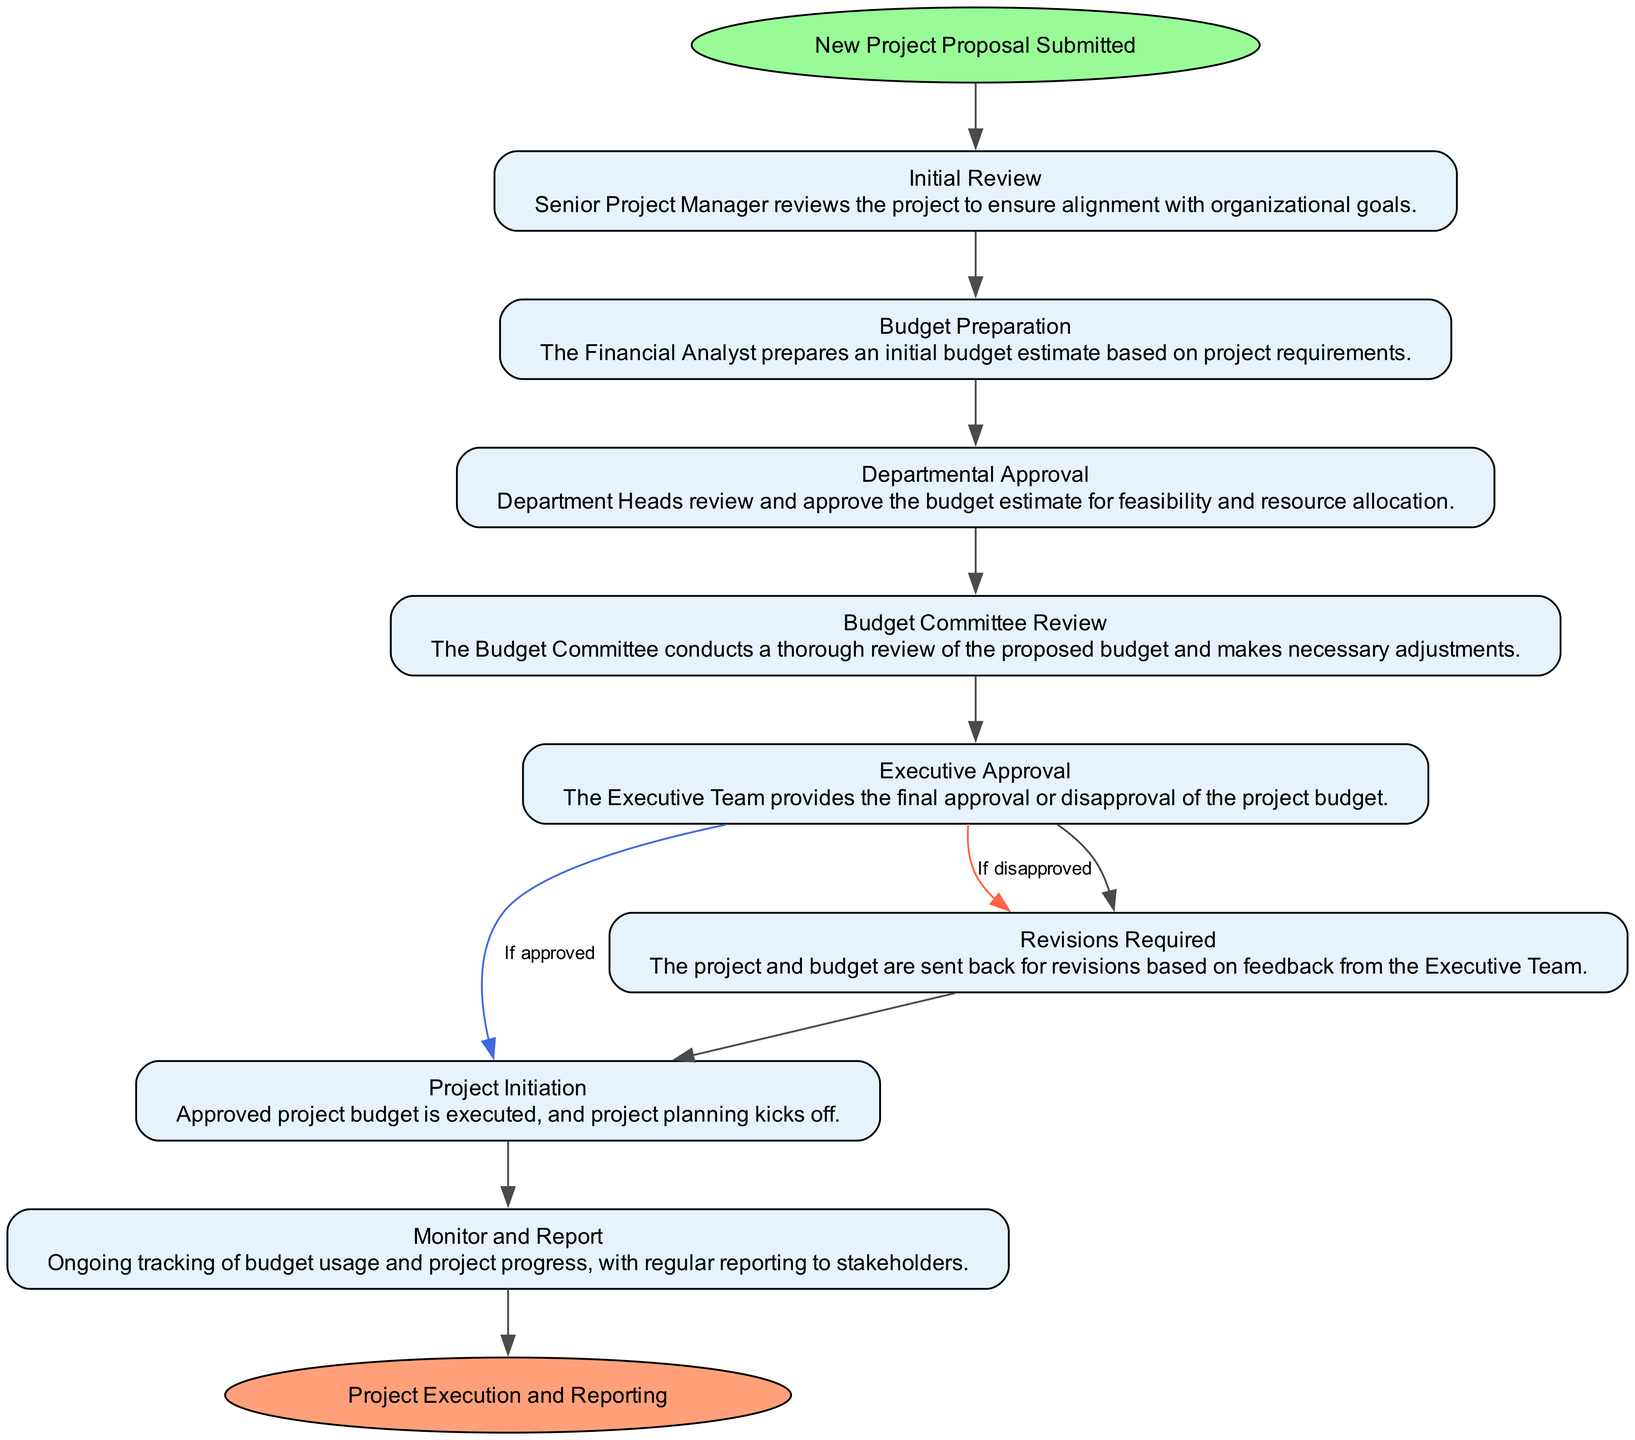What is the starting node of the workflow? The starting node is defined in the diagram as the first step in the process where the project begins, which is "New Project Proposal Submitted".
Answer: New Project Proposal Submitted How many steps are there in the workflow? There are eight distinct steps shown in the flowchart from the initial review to project execution and reporting.
Answer: 8 What is the first action taken after the "Initial Review"? The first action following the "Initial Review" step is "Budget Preparation", which means the financial analyst prepares an initial budget estimate.
Answer: Budget Preparation What happens if the Executive Team disapproves the budget? If the Executive Team disapproves the budget, the process leads to the "Revisions Required" step where feedback is provided to revise the budget.
Answer: Revisions Required What is the final step in the workflow? The final step outlined in the diagram concludes the entire workflow, indicating the successful completion of the project processes.
Answer: Project Execution and Reporting What step directly follows "Budget Committee Review"? The step that follows "Budget Committee Review" is "Executive Approval", where the Executive Team reviews the budget once more for final approval or disapproval.
Answer: Executive Approval How does "Revisions Required" relate to "Budget Preparation"? After revisions are required based on the Executive Team's feedback, the workflow indicates that it loops back to "Budget Preparation" for budget adjustments.
Answer: It loops back to Budget Preparation How many conditional paths are present in the workflow? There are two conditional paths stemming from the "Executive Approval" step: one for approval and one for disapproval, leading to different subsequent actions.
Answer: 2 